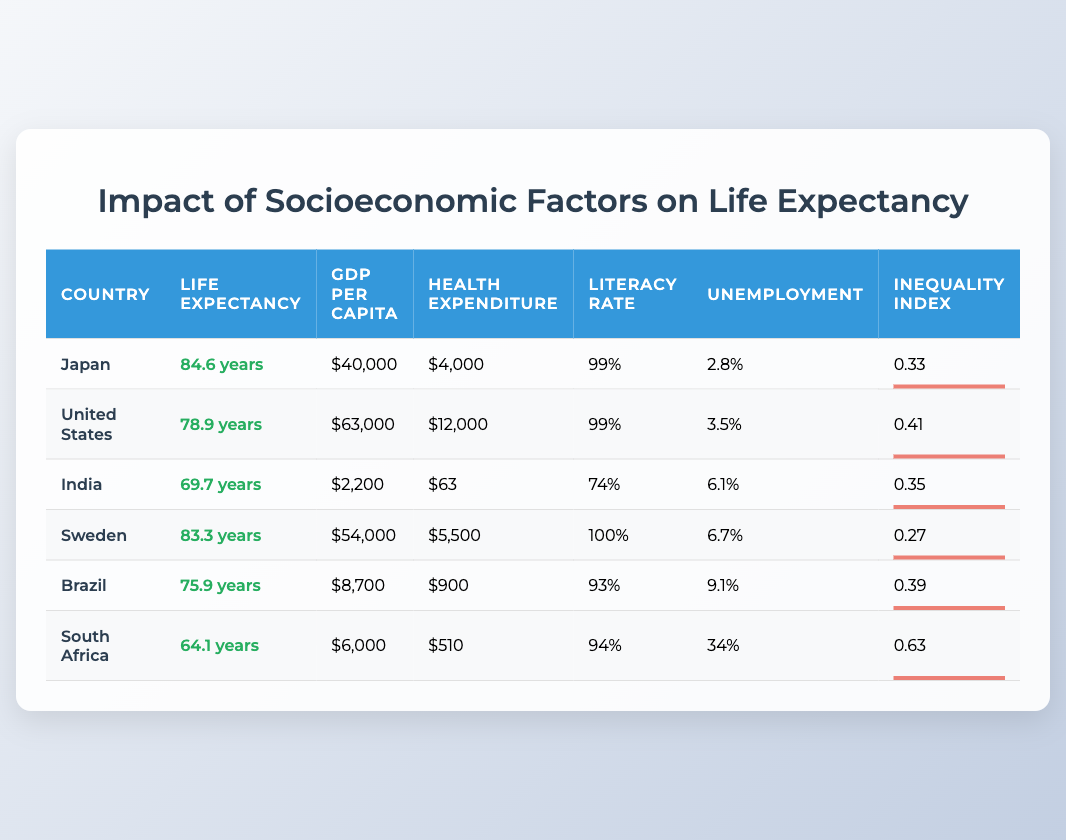What is the average life expectancy of Sweden? The life expectancy for Sweden, as shown in the table, is 83.3 years.
Answer: 83.3 years Which country has the highest GDP per capita? The table shows that the United States has the highest GDP per capita at $63,000.
Answer: United States Is the literacy rate in Brazil higher than in India? The literacy rate in Brazil is 93% and in India it is 74%. Therefore, Brazil's literacy rate is higher than India's.
Answer: Yes What is the difference in average life expectancy between Japan and South Africa? Japan's life expectancy is 84.6 years and South Africa's is 64.1 years. The difference is 84.6 - 64.1 = 20.5 years.
Answer: 20.5 years What is the average health expenditure per capita for all listed countries? Adding the health expenditures: 4000 + 12000 + 63 + 5500 + 900 + 510 = 21073, then dividing by 6 gives an average of 3512.17.
Answer: 3512.17 Does Japan have a higher income inequality index than Sweden? Japan's income inequality index is 0.33, while Sweden's is 0.27. Since 0.33 is greater than 0.27, Japan has a higher index.
Answer: Yes Which country shows the highest unemployment rate? South Africa has the highest unemployment rate at 34%, as seen in the table.
Answer: South Africa What is the median GDP per capita from the countries listed? The GDP per capita values are: $2,200, $6,000, $8,700, $40,000, $54,000, and $63,000. Arranging these values, the median is the average of the third and fourth values: (8,700 + 40,000) / 2 = 24,350.
Answer: 24,350 How does the health expenditure per capita in the United States compare to that in India? The health expenditure per capita in the United States is $12,000, while in India it is $63. Therefore, the United States has a significantly higher health expenditure per capita.
Answer: United States has higher health expenditure 